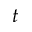<formula> <loc_0><loc_0><loc_500><loc_500>t</formula> 